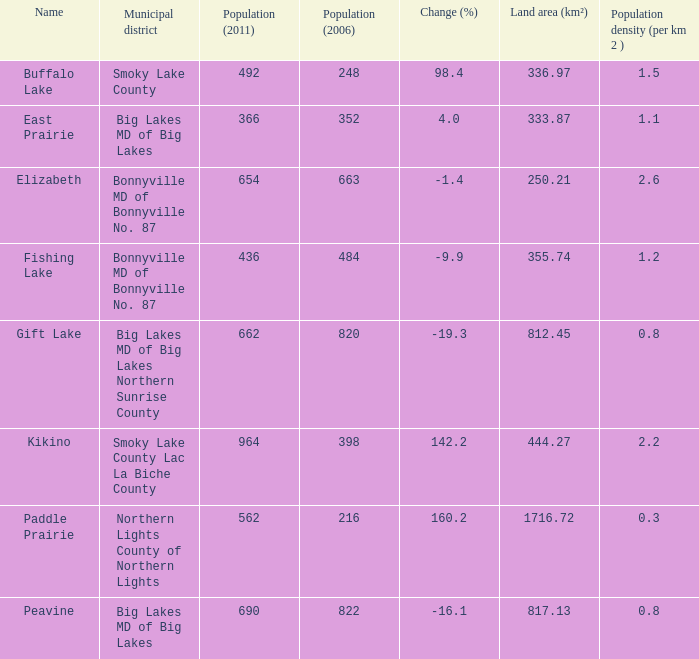What is the number of people per square kilometer in smoky lake county? 1.5. 